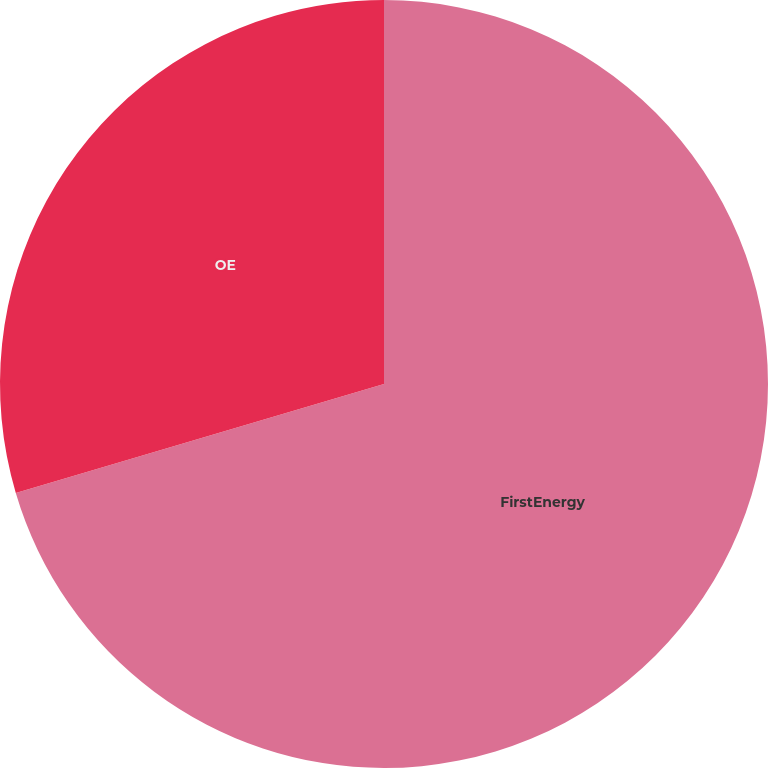Convert chart. <chart><loc_0><loc_0><loc_500><loc_500><pie_chart><fcel>FirstEnergy<fcel>OE<nl><fcel>70.42%<fcel>29.58%<nl></chart> 